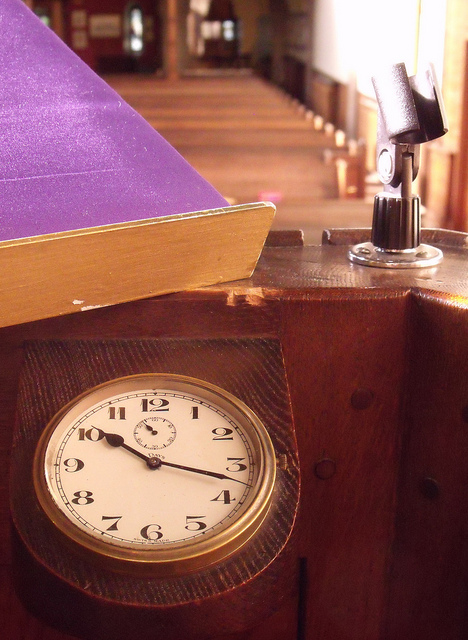Read all the text in this image. 12 11 1 2 10 3 4 5 6 7 8 9 